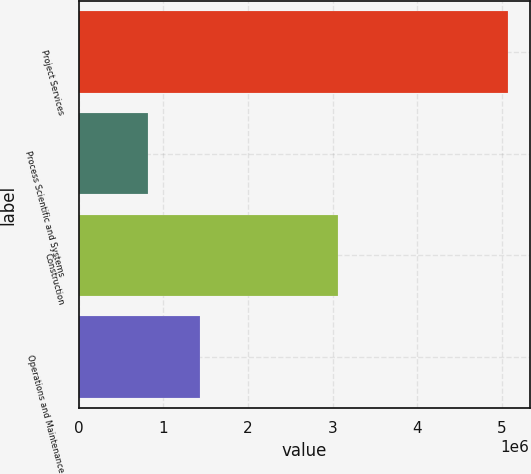Convert chart. <chart><loc_0><loc_0><loc_500><loc_500><bar_chart><fcel>Project Services<fcel>Process Scientific and Systems<fcel>Construction<fcel>Operations and Maintenance<nl><fcel>5.07058e+06<fcel>815561<fcel>3.06082e+06<fcel>1.43471e+06<nl></chart> 